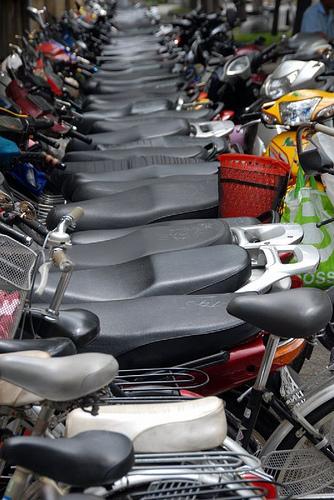What color are the seats?
Answer briefly. Black. Are these bikes parked at the same time?
Quick response, please. Yes. Is there space for another bike in the photo?
Give a very brief answer. No. 